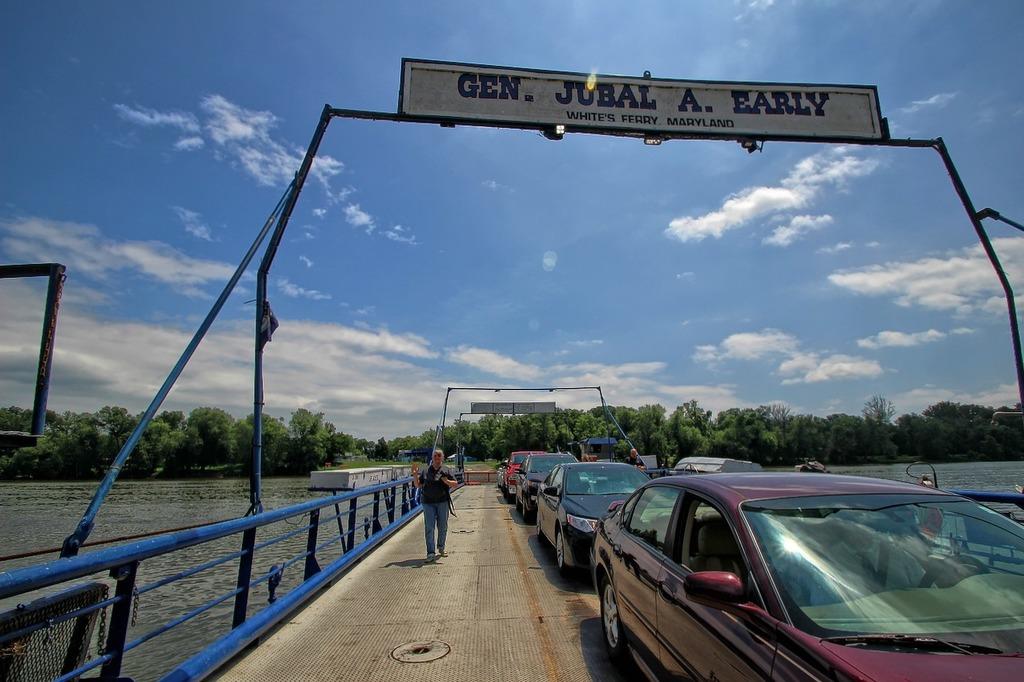What do the large letters on the sign say?
Make the answer very short. Gen. jubal a. early. What state is this ferry in?
Offer a terse response. Maryland. 